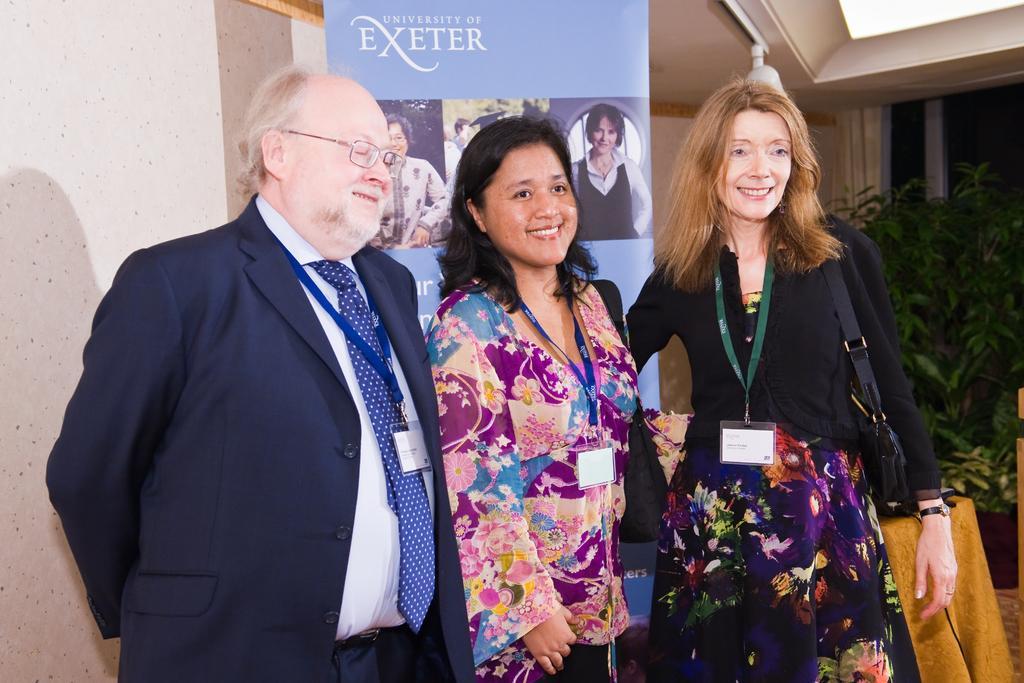Can you describe this image briefly? In the picture we can see a man and two women are standing and man is wearing a blazer with blue tie, shirt and a tag with ID card and two women are wearing a tags with ID cards and in the background we can see a wall and near to it we can see some plants. 